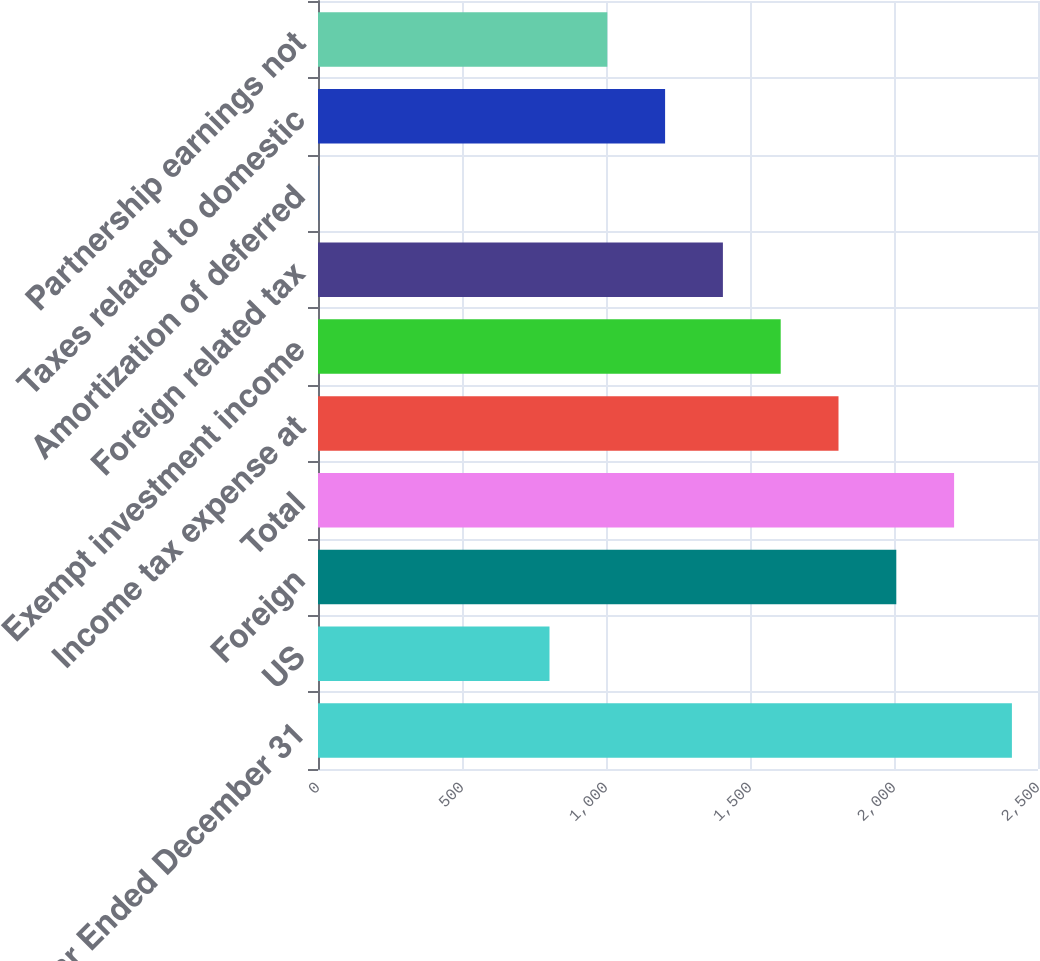Convert chart. <chart><loc_0><loc_0><loc_500><loc_500><bar_chart><fcel>Year Ended December 31<fcel>US<fcel>Foreign<fcel>Total<fcel>Income tax expense at<fcel>Exempt investment income<fcel>Foreign related tax<fcel>Amortization of deferred<fcel>Taxes related to domestic<fcel>Partnership earnings not<nl><fcel>2409.4<fcel>803.8<fcel>2008<fcel>2208.7<fcel>1807.3<fcel>1606.6<fcel>1405.9<fcel>1<fcel>1205.2<fcel>1004.5<nl></chart> 